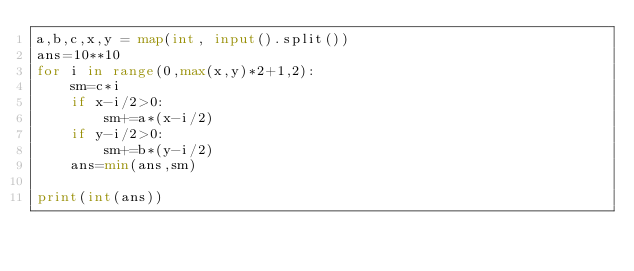Convert code to text. <code><loc_0><loc_0><loc_500><loc_500><_Python_>a,b,c,x,y = map(int, input().split())
ans=10**10
for i in range(0,max(x,y)*2+1,2):
    sm=c*i
    if x-i/2>0:
        sm+=a*(x-i/2)
    if y-i/2>0:
        sm+=b*(y-i/2)
    ans=min(ans,sm)

print(int(ans))
</code> 